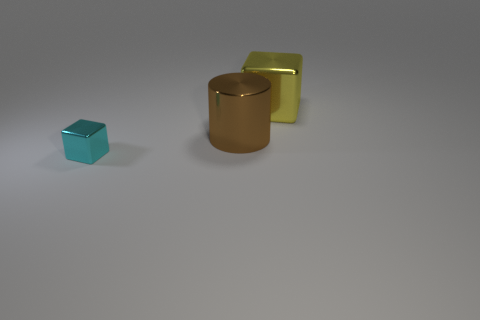Is the number of yellow blocks greater than the number of metal things?
Give a very brief answer. No. Do the metal cylinder and the tiny cube have the same color?
Offer a terse response. No. How many objects are gray things or blocks that are behind the large brown metal cylinder?
Offer a very short reply. 1. What number of other things are the same shape as the big yellow object?
Keep it short and to the point. 1. Is the number of tiny cyan metallic cubes that are behind the large yellow metallic thing less than the number of large cylinders in front of the small cyan shiny block?
Make the answer very short. No. Are there any other things that are the same material as the small cyan thing?
Keep it short and to the point. Yes. There is a big brown object that is made of the same material as the cyan cube; what is its shape?
Your answer should be very brief. Cylinder. Is there anything else that has the same color as the tiny object?
Your answer should be compact. No. There is a block to the right of the metallic cube to the left of the big block; what color is it?
Offer a very short reply. Yellow. The large thing behind the big thing on the left side of the thing behind the brown object is made of what material?
Your answer should be very brief. Metal. 